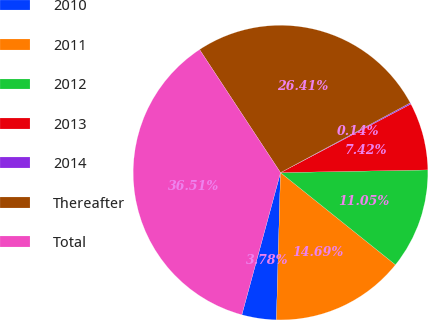<chart> <loc_0><loc_0><loc_500><loc_500><pie_chart><fcel>2010<fcel>2011<fcel>2012<fcel>2013<fcel>2014<fcel>Thereafter<fcel>Total<nl><fcel>3.78%<fcel>14.69%<fcel>11.05%<fcel>7.42%<fcel>0.14%<fcel>26.41%<fcel>36.51%<nl></chart> 